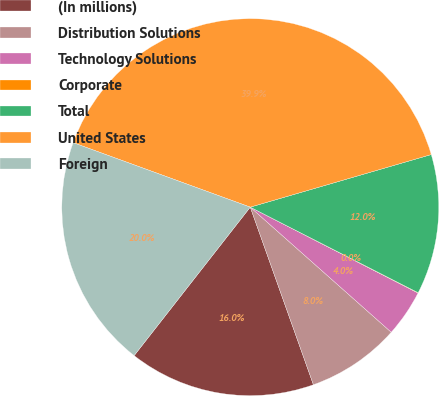Convert chart to OTSL. <chart><loc_0><loc_0><loc_500><loc_500><pie_chart><fcel>(In millions)<fcel>Distribution Solutions<fcel>Technology Solutions<fcel>Corporate<fcel>Total<fcel>United States<fcel>Foreign<nl><fcel>16.0%<fcel>8.01%<fcel>4.02%<fcel>0.03%<fcel>12.0%<fcel>39.94%<fcel>19.99%<nl></chart> 